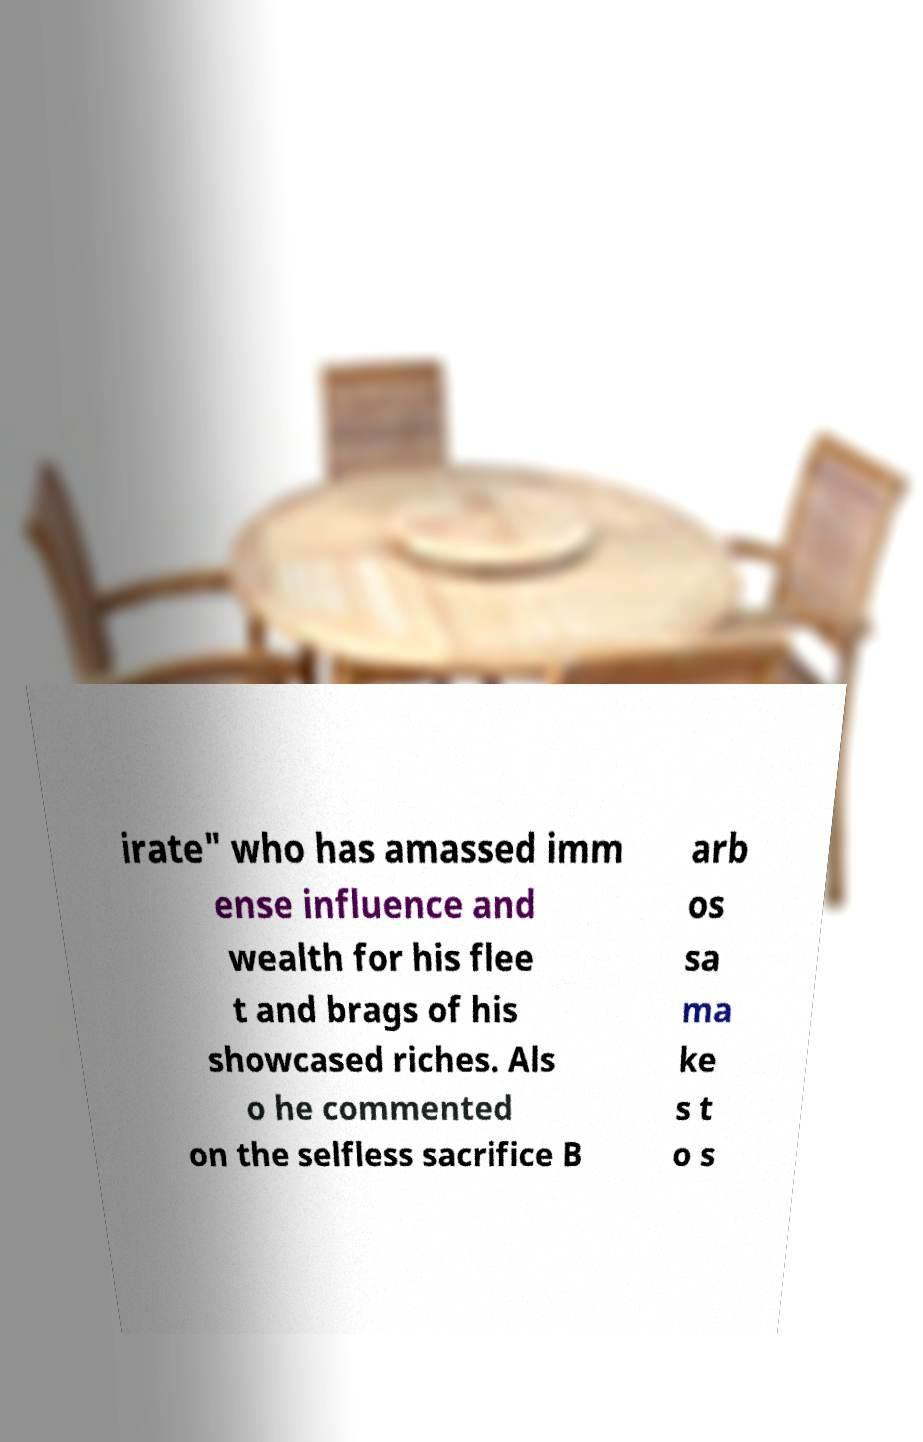I need the written content from this picture converted into text. Can you do that? irate" who has amassed imm ense influence and wealth for his flee t and brags of his showcased riches. Als o he commented on the selfless sacrifice B arb os sa ma ke s t o s 